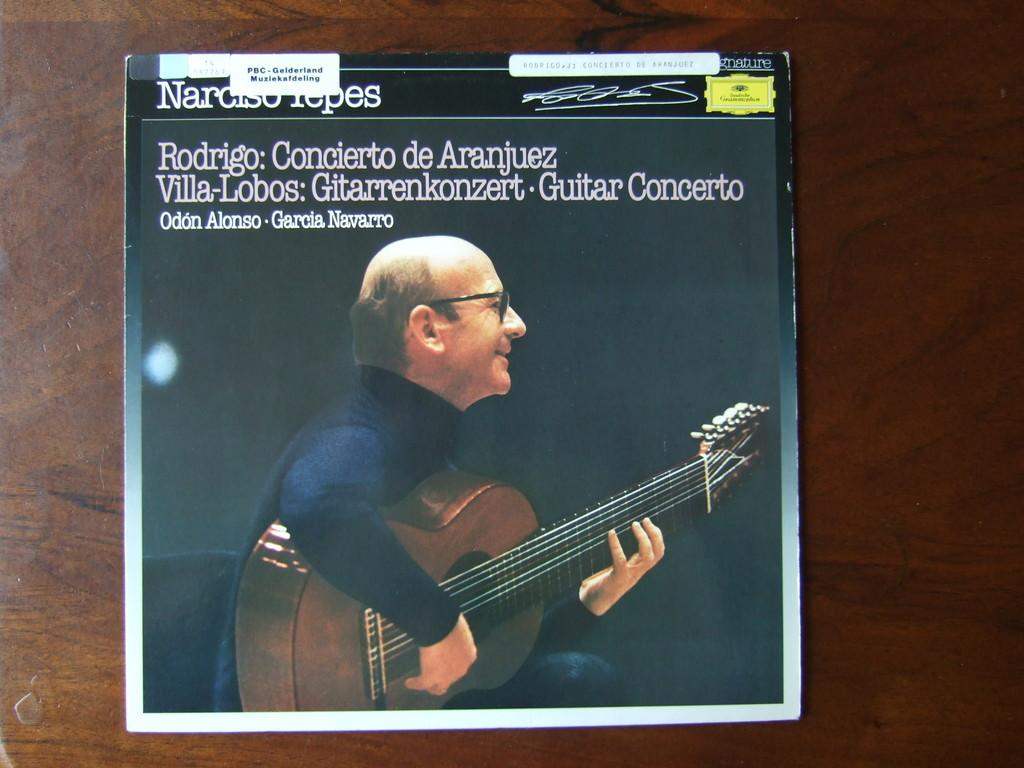What is present in the image that features printed content? There is a poster in the image that features printed content. Where is the poster located in the image? The poster is on a surface in the image. What can be seen on the poster besides the text? There is an image on the poster. What type of information is present on the poster? The poster contains text. What type of gold loaf is being held by the sister in the image? There is no sister, gold, or loaf present in the image. 